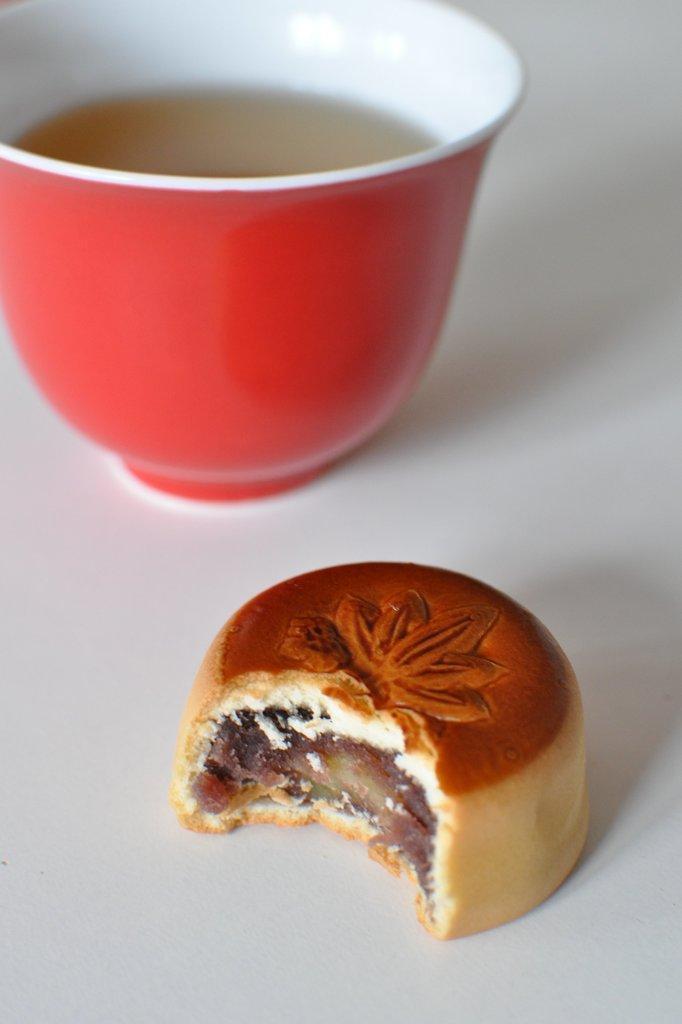Please provide a concise description of this image. In this image I can see a food and red cup on the white surface. Liquid is in the red cup. 